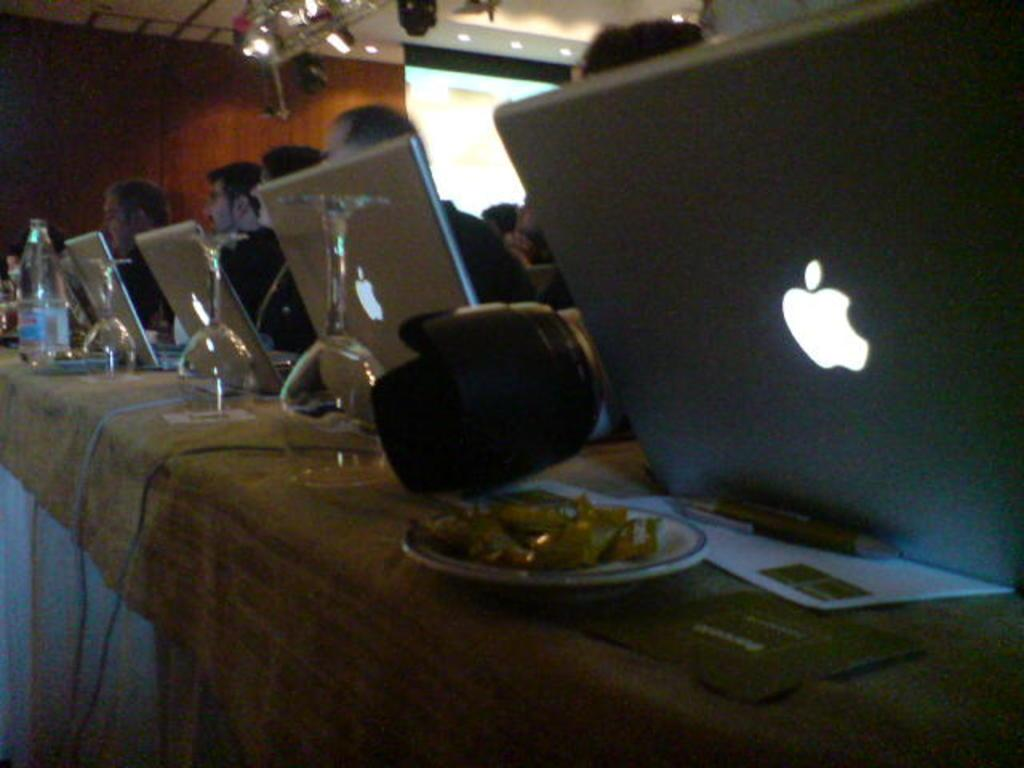What electronic devices can be seen in the room? There are multiple laptops in the room. What are the people in the room doing with the laptops? People are operating the laptops while sitting behind them. What type of furniture is present in the room? There is a table in the room. What items can be seen on the table? There are plates with food and glasses on the table. What type of cream is being served on the desk in the image? There is no cream or desk present in the image; it features laptops, people operating them, a table, plates with food, and glasses. 